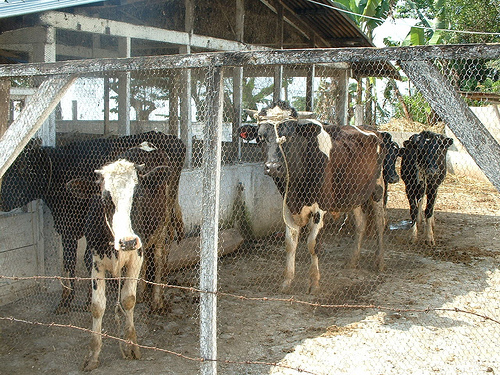Can you describe the cow that is farthest back in the enclosure? What is its behavior telling us? The cow situated at the farthest end of the enclosure, distinguishable by its predominantly black coat with white patches, seems to be enjoying a moment of rest or perhaps chewing cud, evidenced by its slightly lifted head and the relaxed posture. This behavior is typical for cows in comfortable surroundings, suggesting the animal is well-adapted to its environment and not in distress. 